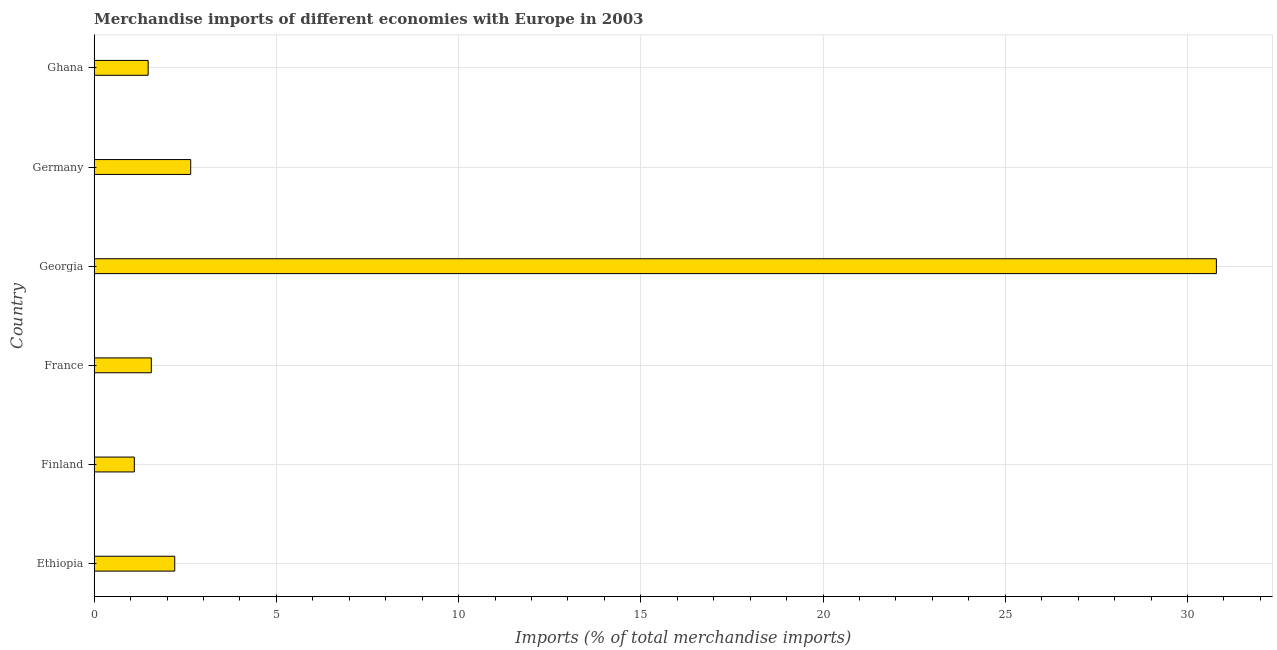Does the graph contain any zero values?
Provide a short and direct response. No. What is the title of the graph?
Your response must be concise. Merchandise imports of different economies with Europe in 2003. What is the label or title of the X-axis?
Provide a succinct answer. Imports (% of total merchandise imports). What is the label or title of the Y-axis?
Provide a succinct answer. Country. What is the merchandise imports in Ghana?
Make the answer very short. 1.48. Across all countries, what is the maximum merchandise imports?
Offer a very short reply. 30.79. Across all countries, what is the minimum merchandise imports?
Ensure brevity in your answer.  1.1. In which country was the merchandise imports maximum?
Make the answer very short. Georgia. In which country was the merchandise imports minimum?
Your answer should be very brief. Finland. What is the sum of the merchandise imports?
Your answer should be compact. 39.8. What is the difference between the merchandise imports in France and Ghana?
Your answer should be very brief. 0.09. What is the average merchandise imports per country?
Your answer should be very brief. 6.63. What is the median merchandise imports?
Give a very brief answer. 1.89. What is the ratio of the merchandise imports in Finland to that in Ghana?
Your answer should be very brief. 0.74. Is the difference between the merchandise imports in Ethiopia and Ghana greater than the difference between any two countries?
Ensure brevity in your answer.  No. What is the difference between the highest and the second highest merchandise imports?
Ensure brevity in your answer.  28.14. Is the sum of the merchandise imports in Ethiopia and Ghana greater than the maximum merchandise imports across all countries?
Provide a short and direct response. No. What is the difference between the highest and the lowest merchandise imports?
Offer a terse response. 29.69. In how many countries, is the merchandise imports greater than the average merchandise imports taken over all countries?
Provide a short and direct response. 1. How many bars are there?
Your answer should be compact. 6. Are the values on the major ticks of X-axis written in scientific E-notation?
Provide a short and direct response. No. What is the Imports (% of total merchandise imports) in Ethiopia?
Provide a short and direct response. 2.21. What is the Imports (% of total merchandise imports) in Finland?
Your answer should be compact. 1.1. What is the Imports (% of total merchandise imports) in France?
Provide a short and direct response. 1.57. What is the Imports (% of total merchandise imports) in Georgia?
Keep it short and to the point. 30.79. What is the Imports (% of total merchandise imports) in Germany?
Offer a very short reply. 2.65. What is the Imports (% of total merchandise imports) in Ghana?
Your response must be concise. 1.48. What is the difference between the Imports (% of total merchandise imports) in Ethiopia and Finland?
Your answer should be compact. 1.11. What is the difference between the Imports (% of total merchandise imports) in Ethiopia and France?
Your answer should be compact. 0.64. What is the difference between the Imports (% of total merchandise imports) in Ethiopia and Georgia?
Ensure brevity in your answer.  -28.58. What is the difference between the Imports (% of total merchandise imports) in Ethiopia and Germany?
Give a very brief answer. -0.44. What is the difference between the Imports (% of total merchandise imports) in Ethiopia and Ghana?
Make the answer very short. 0.73. What is the difference between the Imports (% of total merchandise imports) in Finland and France?
Make the answer very short. -0.47. What is the difference between the Imports (% of total merchandise imports) in Finland and Georgia?
Your answer should be compact. -29.69. What is the difference between the Imports (% of total merchandise imports) in Finland and Germany?
Ensure brevity in your answer.  -1.55. What is the difference between the Imports (% of total merchandise imports) in Finland and Ghana?
Your answer should be very brief. -0.38. What is the difference between the Imports (% of total merchandise imports) in France and Georgia?
Make the answer very short. -29.22. What is the difference between the Imports (% of total merchandise imports) in France and Germany?
Provide a succinct answer. -1.08. What is the difference between the Imports (% of total merchandise imports) in France and Ghana?
Your response must be concise. 0.09. What is the difference between the Imports (% of total merchandise imports) in Georgia and Germany?
Your answer should be compact. 28.14. What is the difference between the Imports (% of total merchandise imports) in Georgia and Ghana?
Provide a succinct answer. 29.31. What is the difference between the Imports (% of total merchandise imports) in Germany and Ghana?
Provide a short and direct response. 1.17. What is the ratio of the Imports (% of total merchandise imports) in Ethiopia to that in Finland?
Ensure brevity in your answer.  2.01. What is the ratio of the Imports (% of total merchandise imports) in Ethiopia to that in France?
Make the answer very short. 1.41. What is the ratio of the Imports (% of total merchandise imports) in Ethiopia to that in Georgia?
Provide a succinct answer. 0.07. What is the ratio of the Imports (% of total merchandise imports) in Ethiopia to that in Germany?
Keep it short and to the point. 0.83. What is the ratio of the Imports (% of total merchandise imports) in Ethiopia to that in Ghana?
Your answer should be compact. 1.49. What is the ratio of the Imports (% of total merchandise imports) in Finland to that in France?
Offer a very short reply. 0.7. What is the ratio of the Imports (% of total merchandise imports) in Finland to that in Georgia?
Your answer should be very brief. 0.04. What is the ratio of the Imports (% of total merchandise imports) in Finland to that in Germany?
Give a very brief answer. 0.42. What is the ratio of the Imports (% of total merchandise imports) in Finland to that in Ghana?
Keep it short and to the point. 0.74. What is the ratio of the Imports (% of total merchandise imports) in France to that in Georgia?
Offer a very short reply. 0.05. What is the ratio of the Imports (% of total merchandise imports) in France to that in Germany?
Provide a succinct answer. 0.59. What is the ratio of the Imports (% of total merchandise imports) in France to that in Ghana?
Your answer should be compact. 1.06. What is the ratio of the Imports (% of total merchandise imports) in Georgia to that in Germany?
Ensure brevity in your answer.  11.63. What is the ratio of the Imports (% of total merchandise imports) in Georgia to that in Ghana?
Ensure brevity in your answer.  20.8. What is the ratio of the Imports (% of total merchandise imports) in Germany to that in Ghana?
Your answer should be very brief. 1.79. 